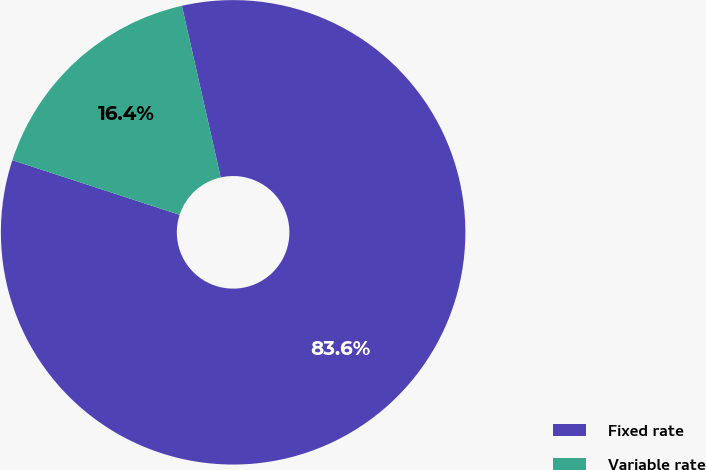<chart> <loc_0><loc_0><loc_500><loc_500><pie_chart><fcel>Fixed rate<fcel>Variable rate<nl><fcel>83.57%<fcel>16.43%<nl></chart> 